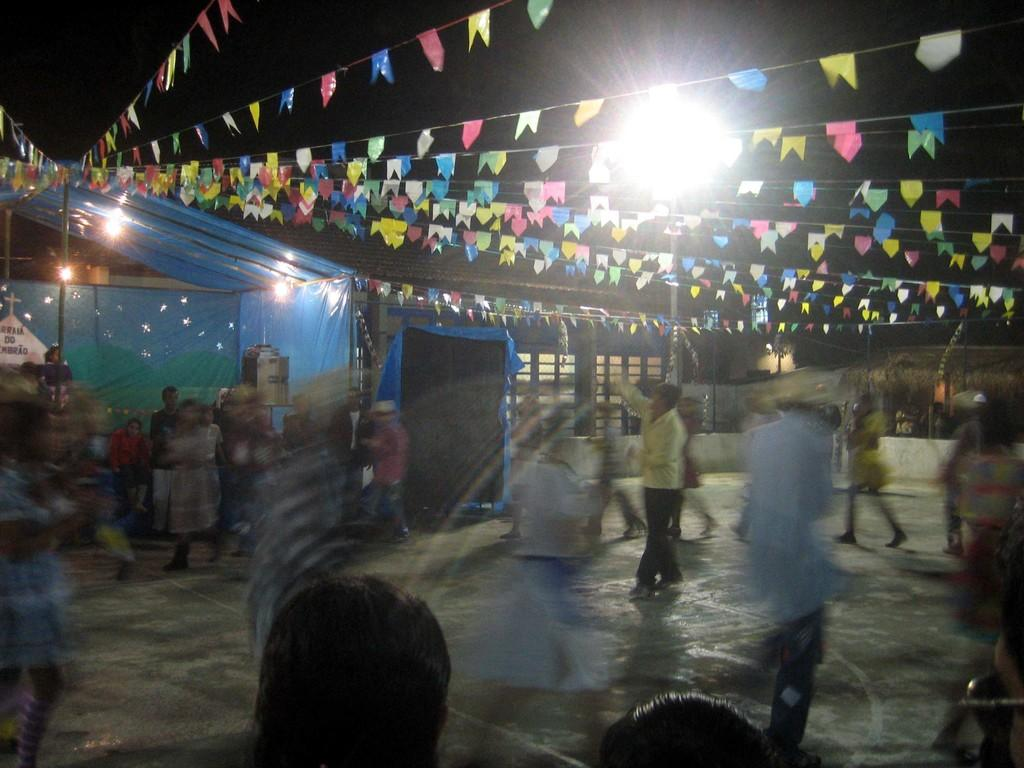How many people are in the group visible in the image? There is a group of people in the image, but the exact number cannot be determined from the provided facts. What can be found on the ground in the image? There are objects on the ground in the image, but their specific nature is not mentioned in the facts. What is located in the background of the image? In the background of the image, there is a tent, decorative flags, lights, and the sky. Can you describe the lighting conditions in the image? The presence of lights in the background of the image suggests that the scene is illuminated, but the specific lighting conditions cannot be determined from the provided facts. How does the digestion of sugar affect the value of the objects on the ground in the image? There is no mention of sugar or digestion in the image, and the value of the objects on the ground is not discussed in the provided facts. 